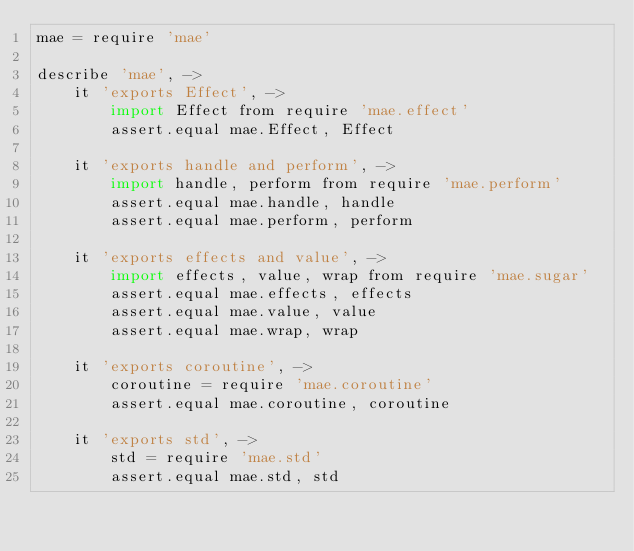<code> <loc_0><loc_0><loc_500><loc_500><_MoonScript_>mae = require 'mae'

describe 'mae', ->
	it 'exports Effect', ->
		import Effect from require 'mae.effect'
		assert.equal mae.Effect, Effect

	it 'exports handle and perform', ->
		import handle, perform from require 'mae.perform'
		assert.equal mae.handle, handle
		assert.equal mae.perform, perform

	it 'exports effects and value', ->
		import effects, value, wrap from require 'mae.sugar'
		assert.equal mae.effects, effects
		assert.equal mae.value, value
		assert.equal mae.wrap, wrap

	it 'exports coroutine', ->
		coroutine = require 'mae.coroutine'
		assert.equal mae.coroutine, coroutine

	it 'exports std', ->
		std = require 'mae.std'
		assert.equal mae.std, std

</code> 